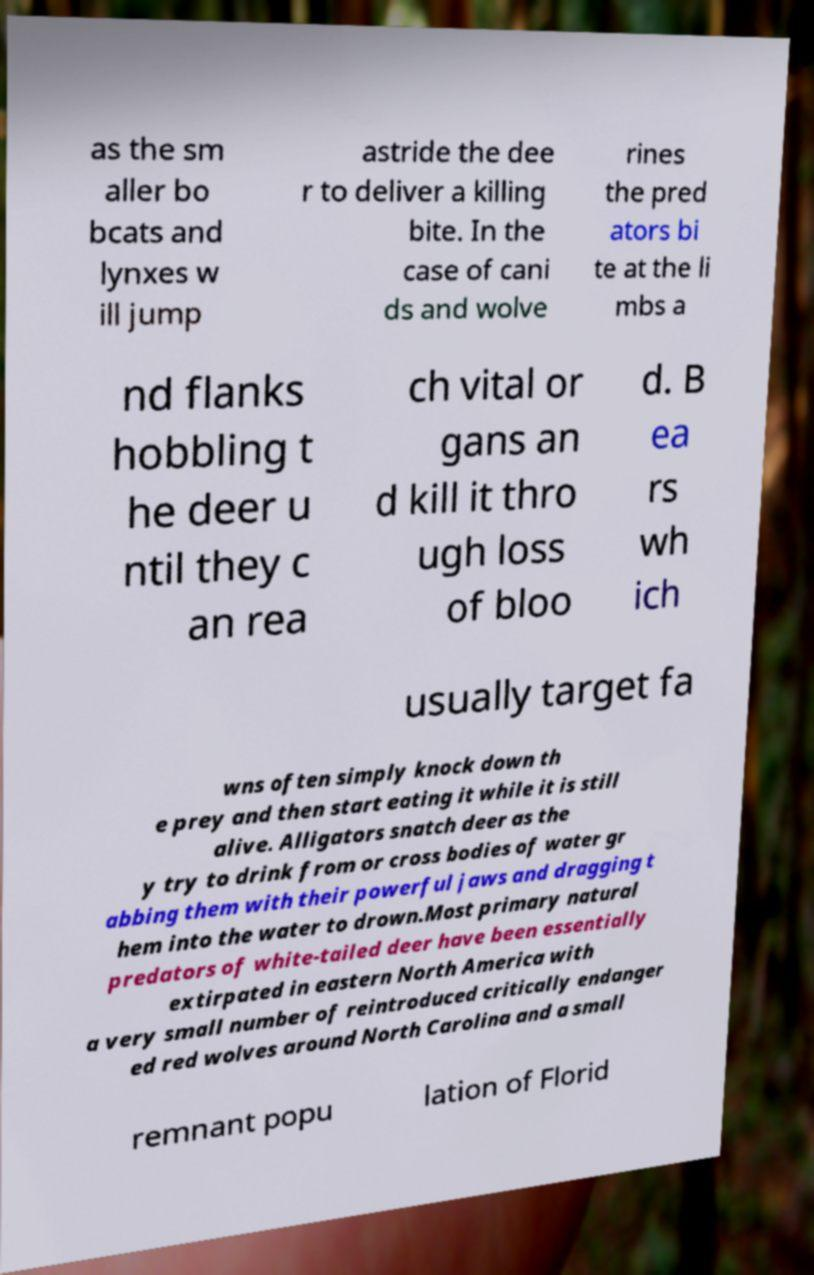Please read and relay the text visible in this image. What does it say? as the sm aller bo bcats and lynxes w ill jump astride the dee r to deliver a killing bite. In the case of cani ds and wolve rines the pred ators bi te at the li mbs a nd flanks hobbling t he deer u ntil they c an rea ch vital or gans an d kill it thro ugh loss of bloo d. B ea rs wh ich usually target fa wns often simply knock down th e prey and then start eating it while it is still alive. Alligators snatch deer as the y try to drink from or cross bodies of water gr abbing them with their powerful jaws and dragging t hem into the water to drown.Most primary natural predators of white-tailed deer have been essentially extirpated in eastern North America with a very small number of reintroduced critically endanger ed red wolves around North Carolina and a small remnant popu lation of Florid 